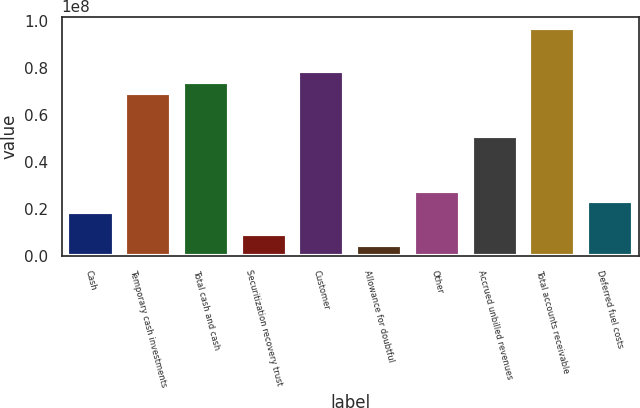<chart> <loc_0><loc_0><loc_500><loc_500><bar_chart><fcel>Cash<fcel>Temporary cash investments<fcel>Total cash and cash<fcel>Securitization recovery trust<fcel>Customer<fcel>Allowance for doubtful<fcel>Other<fcel>Accrued unbilled revenues<fcel>Total accounts receivable<fcel>Deferred fuel costs<nl><fcel>1.84891e+07<fcel>6.92876e+07<fcel>7.39057e+07<fcel>9.25298e+06<fcel>7.85237e+07<fcel>4.63493e+06<fcel>2.77252e+07<fcel>5.08154e+07<fcel>9.69959e+07<fcel>2.31071e+07<nl></chart> 